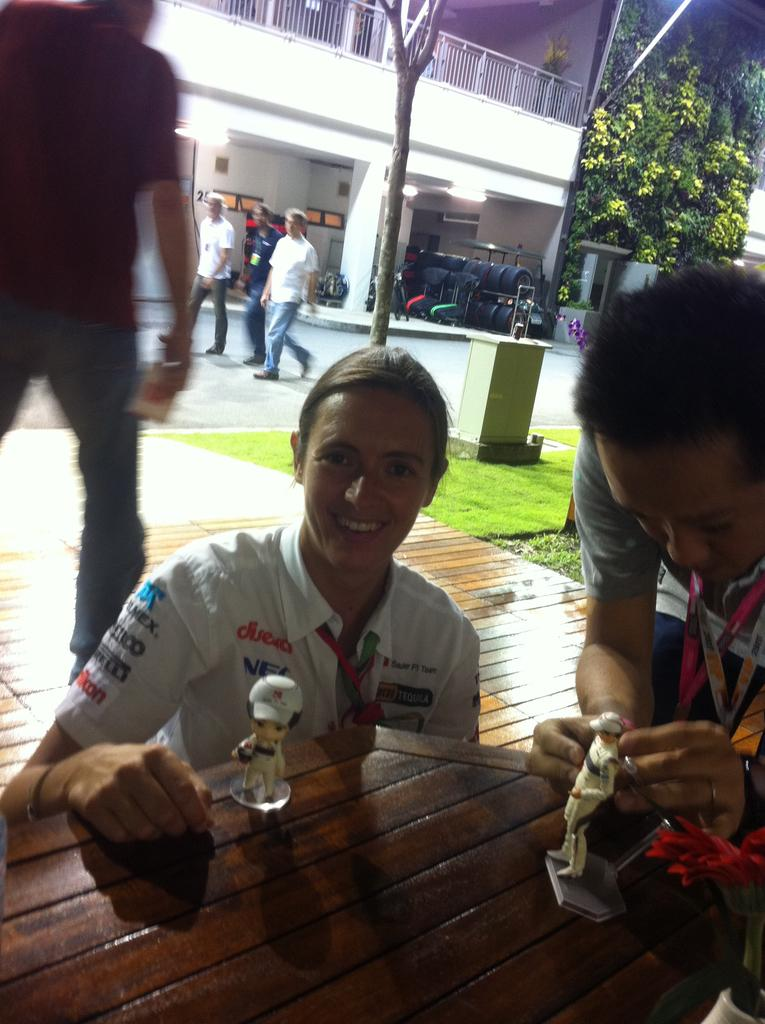How many people are present in the image? There are three people in the image. What are the two people in front of doing? They are sitting at a table with toys in front of them. What can be seen in the background of the image? There is grass, trees, a building, a fence, and tires in the background of the image. Are there any other people visible in the image? Yes, there are three people walking in the background of the image. What type of cow can be seen grazing in the background of the image? There is no cow present in the image; it features three people and various background elements. How does the wealth of the people in the image compare to that of their neighbors? The image does not provide any information about the wealth of the people or their neighbors. 